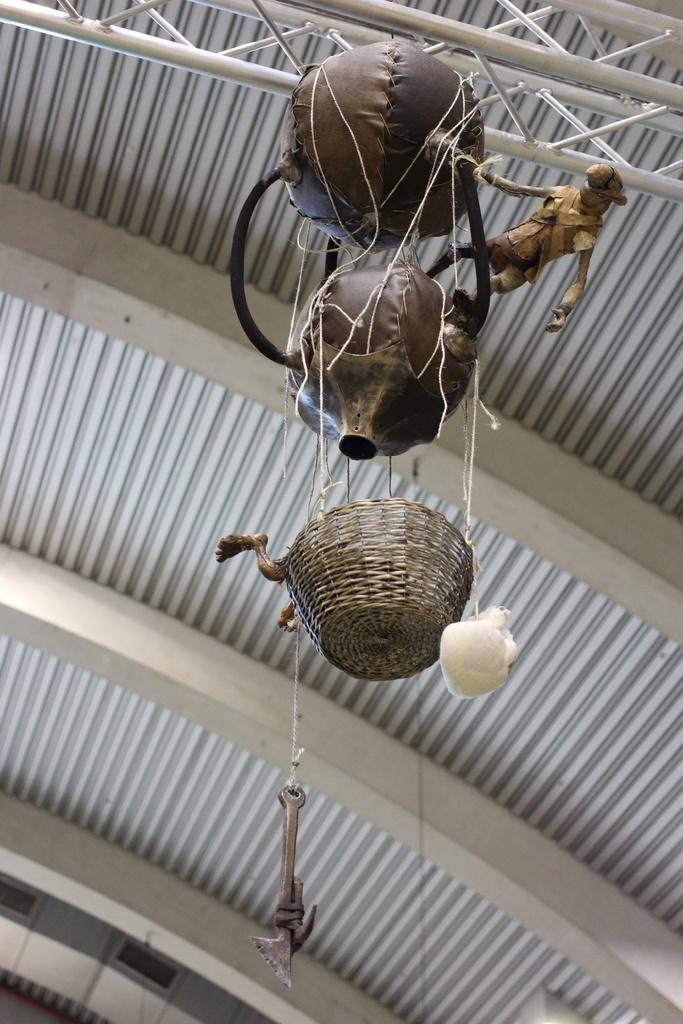Could you give a brief overview of what you see in this image? In this image I can see in the middle there are decorative things, at the top there are metal rods. In the background it looks there are metal sheets. 